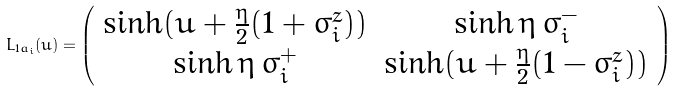<formula> <loc_0><loc_0><loc_500><loc_500>L _ { 1 a _ { i } } ( u ) = \left ( \begin{array} { c c } \sinh ( u + \frac { \eta } { 2 } ( 1 + \sigma _ { i } ^ { z } ) ) & \sinh \eta \, \sigma _ { i } ^ { - } \\ \sinh \eta \, \sigma _ { i } ^ { + } & \sinh ( u + \frac { \eta } { 2 } ( 1 - \sigma _ { i } ^ { z } ) ) \end{array} \right )</formula> 